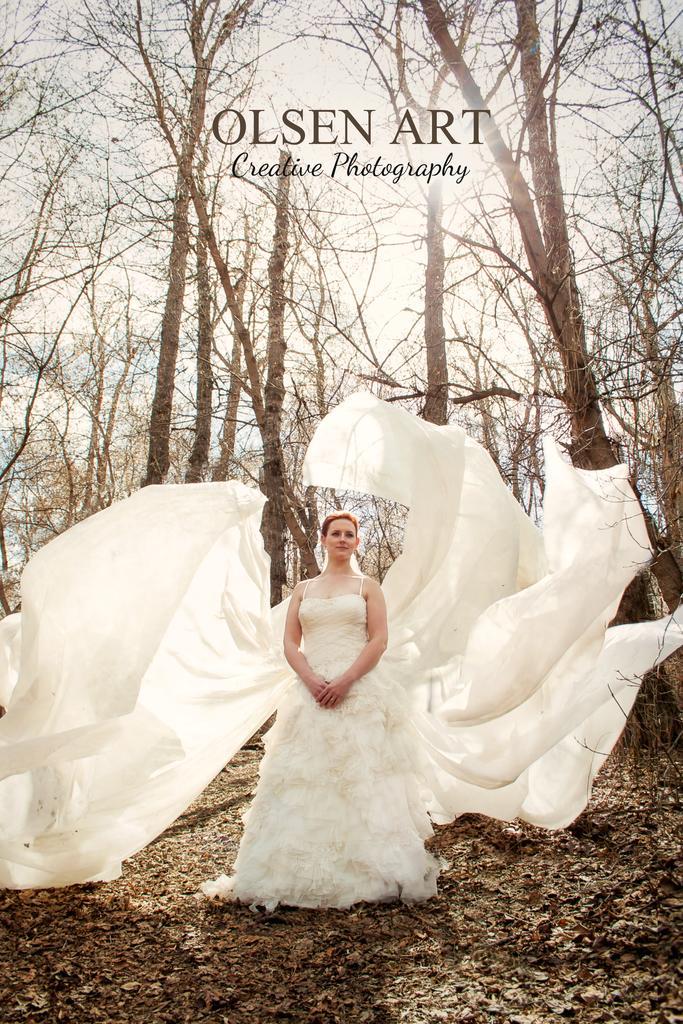Describe this image in one or two sentences. In this picture I can observe a woman standing on land in the middle of the picture. She is wearing white color dress. In the background I can observe trees. In the top of the picture I can observe watermark. 